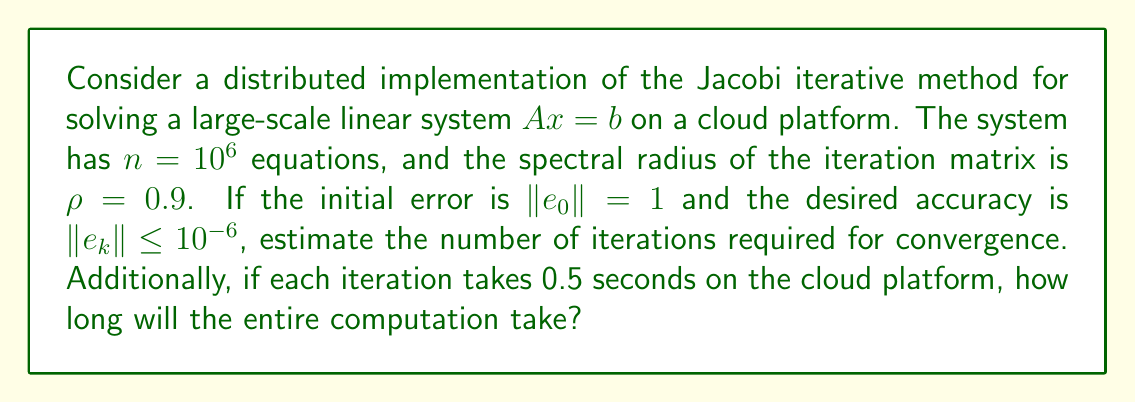Help me with this question. To solve this problem, we'll follow these steps:

1) For the Jacobi method, the convergence rate is determined by the spectral radius $\rho$ of the iteration matrix. The error after $k$ iterations is approximately:

   $$\|e_k\| \approx \rho^k \|e_0\|$$

2) We want to find $k$ such that:

   $$\rho^k \|e_0\| \leq 10^{-6}$$

3) Taking logarithms of both sides:

   $$k \log \rho + \log \|e_0\| \leq \log(10^{-6})$$

4) Solving for $k$:

   $$k \geq \frac{\log(10^{-6}) - \log \|e_0\|}{\log \rho}$$

5) Substituting the given values:

   $$k \geq \frac{\log(10^{-6}) - \log(1)}{\log(0.9)}$$

6) Calculating:

   $$k \geq \frac{-13.8155}{-0.1054} \approx 131.08$$

7) Since $k$ must be an integer, we round up:

   $$k = 132\text{ iterations}$$

8) To find the total computation time:

   $$\text{Total time} = 132 \times 0.5\text{ seconds} = 66\text{ seconds}$$
Answer: The Jacobi method will require 132 iterations to converge to the desired accuracy, and the total computation time on the cloud platform will be 66 seconds. 